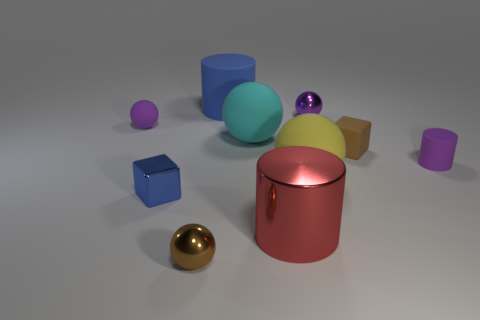The purple matte object that is in front of the small rubber sphere has what shape? The purple matte object situated in front of the small rubber sphere boasts a cylindrical shape. Its smooth surface and elongated structure are characteristic of cylinders, setting it apart from the other variously shaped and colored objects visible in the image. 